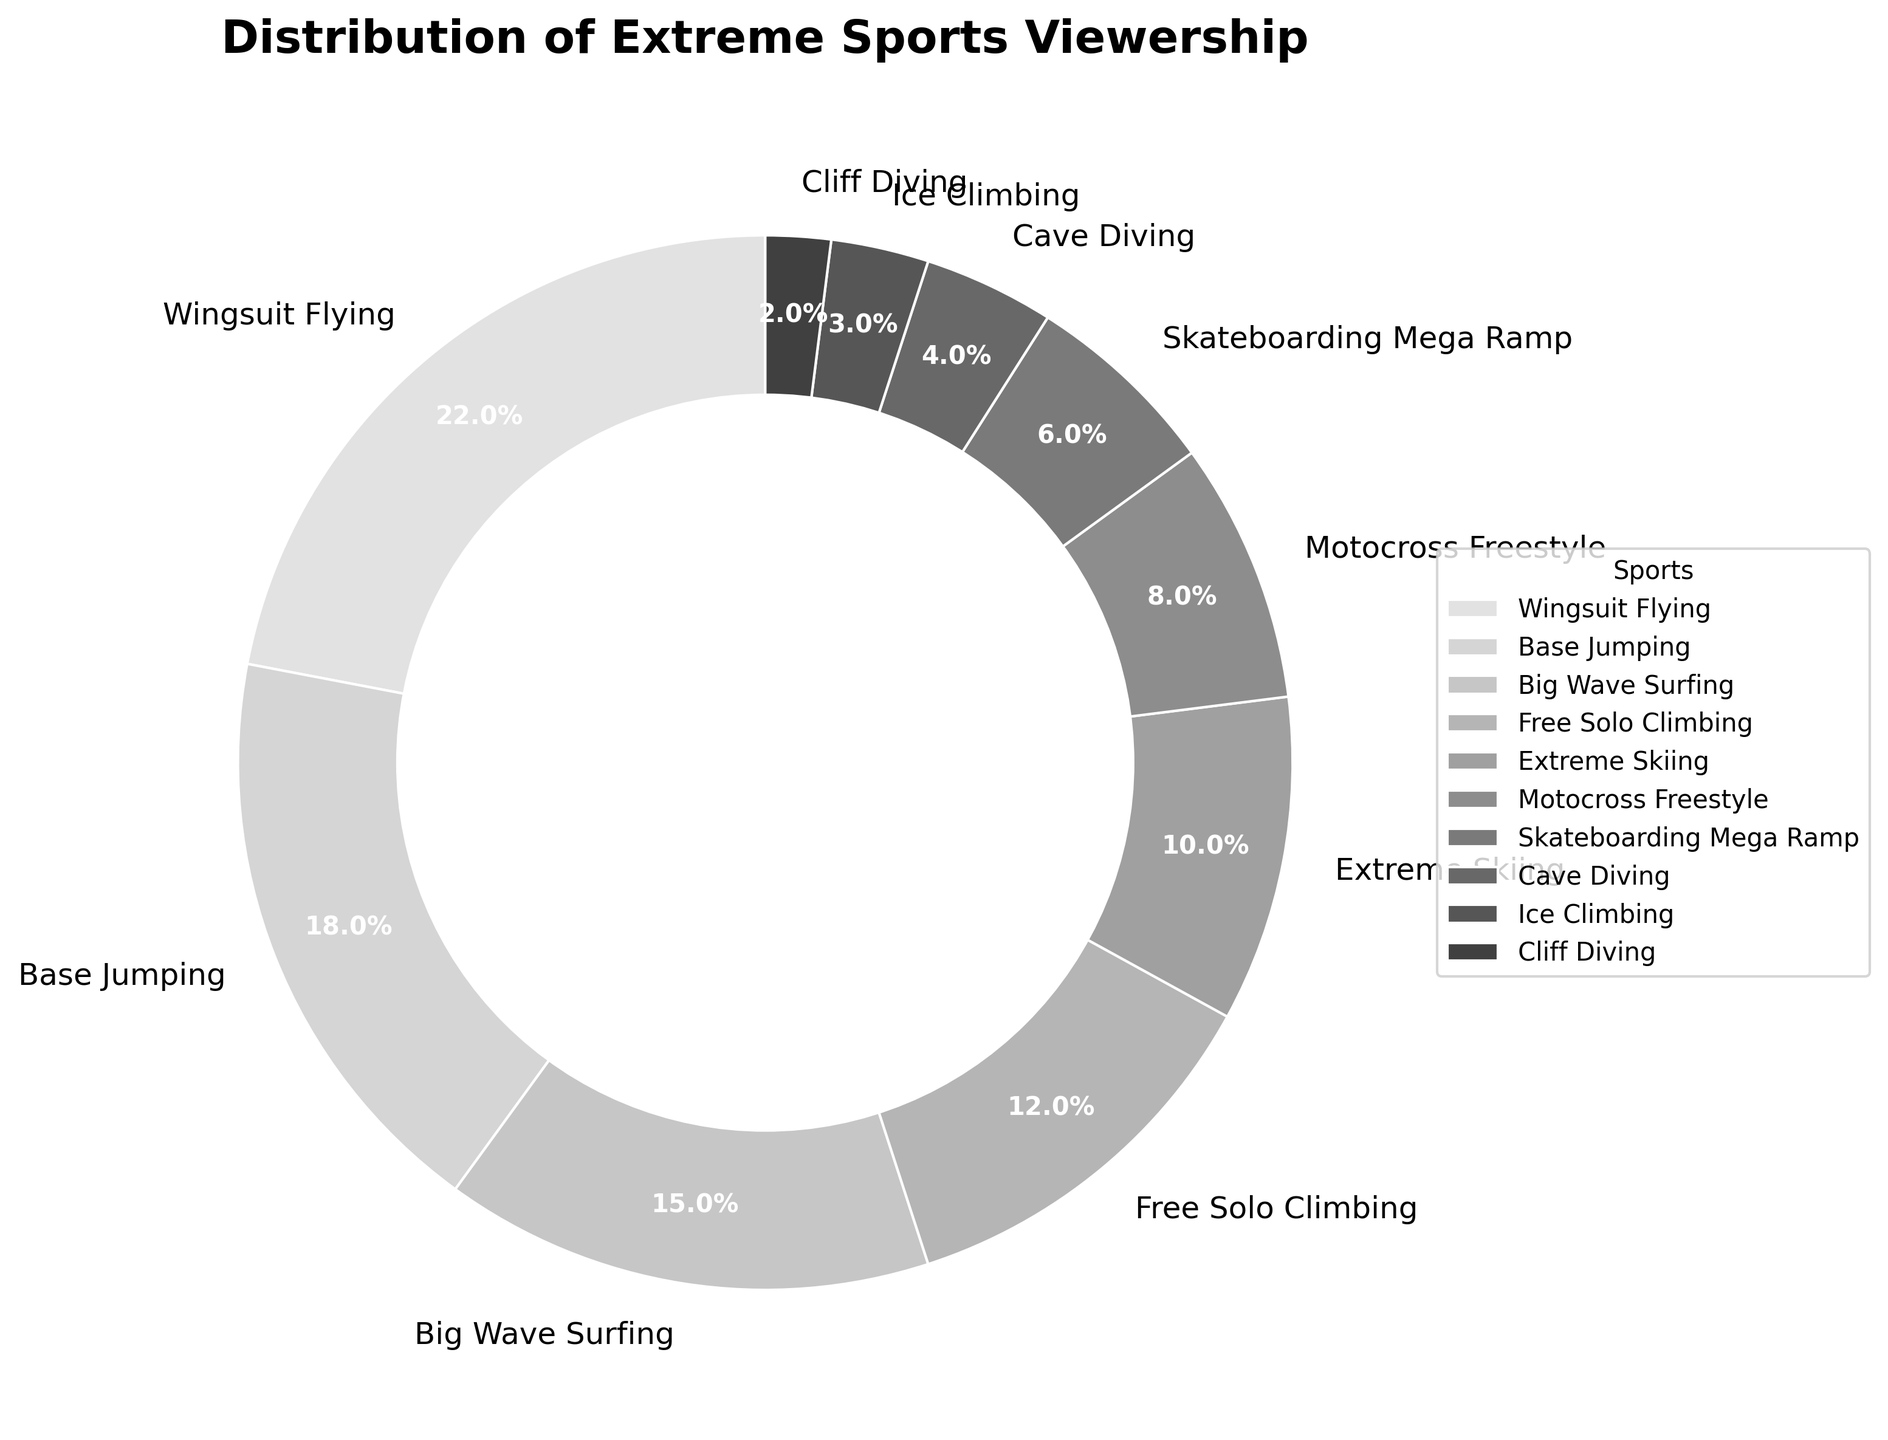What sport has the highest viewership percentage? The figure shows different sports labeled with their viewership percentages, and Wingsuit Flying has the highest percentage at 22%.
Answer: Wingsuit Flying What is the total viewership percentage of sports with less than 10% viewership each? By referring to the figure, identify sports with less than 10%: Motocross Freestyle (8%), Skateboarding Mega Ramp (6%), Cave Diving (4%), Ice Climbing (3%), and Cliff Diving (2%). Sum these percentages: 8% + 6% + 4% + 3% + 2% = 23%.
Answer: 23% Which two sports combined have a percentage closest to Wingsuit Flying's viewership percentage? Identify pairs of sports and their percentages: Base Jumping (18%) + Cliff Diving (2%) = 20%, Extreme Skiing (10%) + Motocross Freestyle (8%) = 18%, Big Wave Surfing (15%) + Ice Climbing (3%) = 18%, etc. Compare to Wingsuit Flying's 22%. The pair closest to 22% is Extreme Skiing (10%) and Motocross Freestyle (8%) summing up to 18%.
Answer: Extreme Skiing and Motocross Freestyle How does the percentage of Big Wave Surfing compare to Free Solo Climbing? Identify the percentages from the figure: Big Wave Surfing (15%) and Free Solo Climbing (12%). Compare 15% with 12%.
Answer: Big Wave Surfing is higher What percentage of viewership is accounted for by sports that have over 10% viewership each? Identify sports with viewership over 10%: Wingsuit Flying (22%), Base Jumping (18%), Big Wave Surfing (15%), and Free Solo Climbing (12%). Sum these percentages: 22% + 18% + 15% + 12% = 67%.
Answer: 67% 